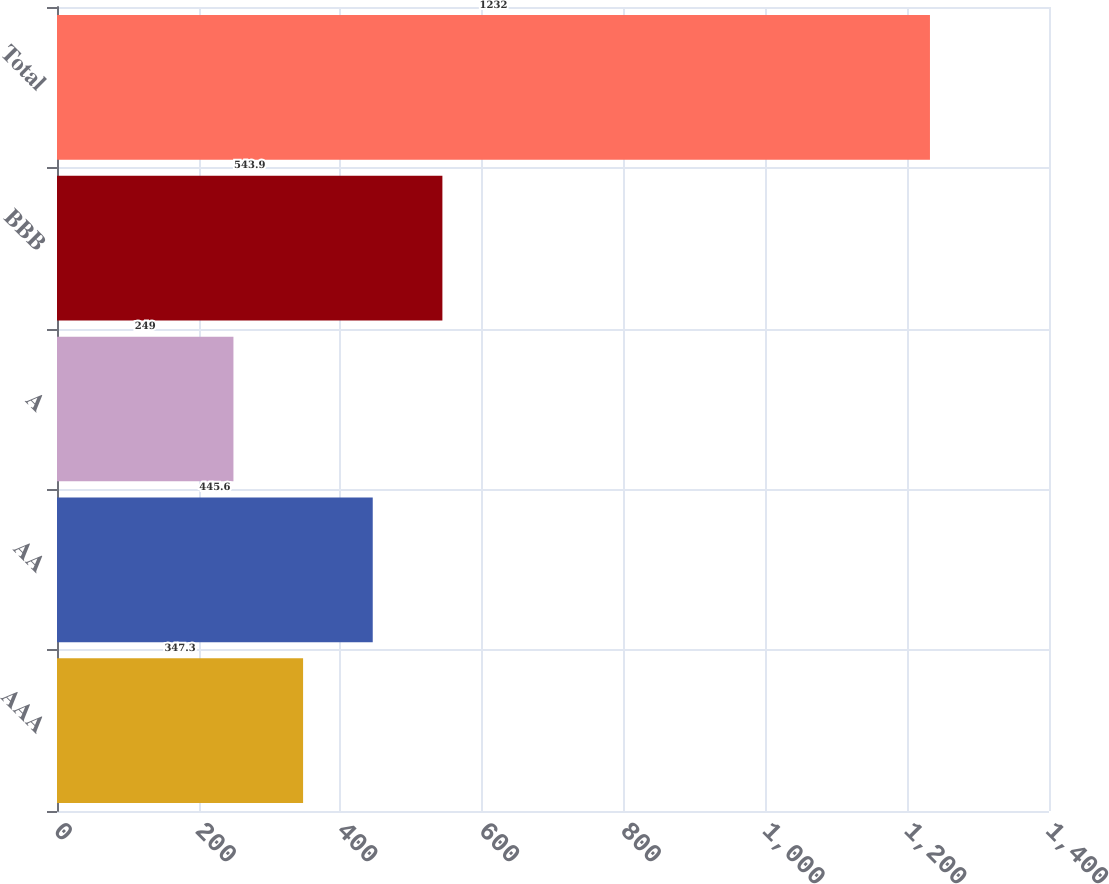Convert chart. <chart><loc_0><loc_0><loc_500><loc_500><bar_chart><fcel>AAA<fcel>AA<fcel>A<fcel>BBB<fcel>Total<nl><fcel>347.3<fcel>445.6<fcel>249<fcel>543.9<fcel>1232<nl></chart> 